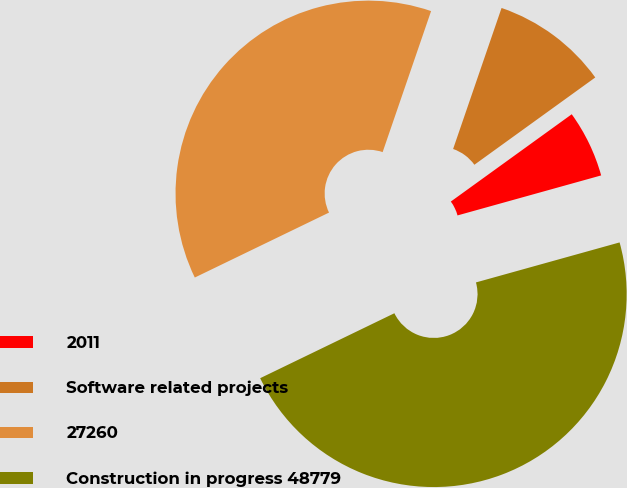Convert chart. <chart><loc_0><loc_0><loc_500><loc_500><pie_chart><fcel>2011<fcel>Software related projects<fcel>27260<fcel>Construction in progress 48779<nl><fcel>5.63%<fcel>9.78%<fcel>37.44%<fcel>47.15%<nl></chart> 